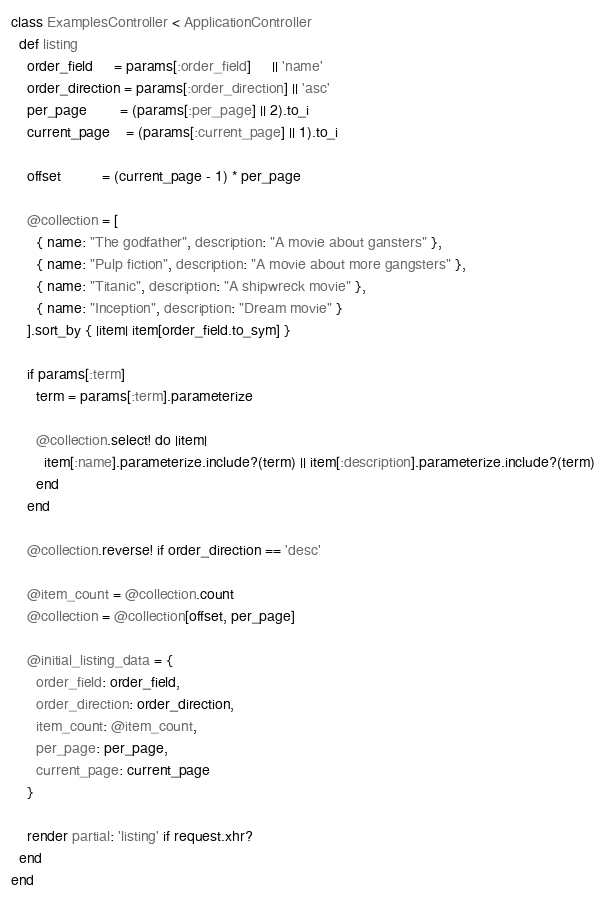Convert code to text. <code><loc_0><loc_0><loc_500><loc_500><_Ruby_>class ExamplesController < ApplicationController
  def listing
    order_field     = params[:order_field]     || 'name'
    order_direction = params[:order_direction] || 'asc'
    per_page        = (params[:per_page] || 2).to_i
    current_page    = (params[:current_page] || 1).to_i

    offset          = (current_page - 1) * per_page

    @collection = [
      { name: "The godfather", description: "A movie about gansters" },
      { name: "Pulp fiction", description: "A movie about more gangsters" },
      { name: "Titanic", description: "A shipwreck movie" },
      { name: "Inception", description: "Dream movie" }
    ].sort_by { |item| item[order_field.to_sym] }

    if params[:term]
      term = params[:term].parameterize

      @collection.select! do |item|
        item[:name].parameterize.include?(term) || item[:description].parameterize.include?(term)
      end
    end

    @collection.reverse! if order_direction == 'desc'

    @item_count = @collection.count
    @collection = @collection[offset, per_page]

    @initial_listing_data = {
      order_field: order_field,
      order_direction: order_direction,
      item_count: @item_count,
      per_page: per_page,
      current_page: current_page
    }

    render partial: 'listing' if request.xhr?
  end
end
</code> 